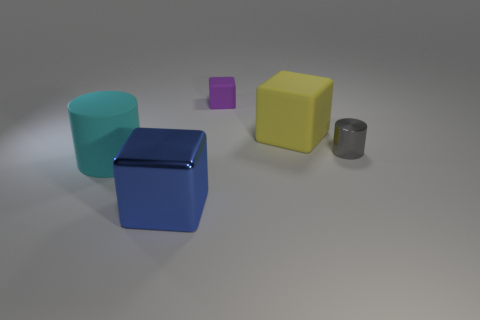Add 5 big yellow matte blocks. How many objects exist? 10 Subtract all purple objects. Subtract all gray cylinders. How many objects are left? 3 Add 4 large cyan cylinders. How many large cyan cylinders are left? 5 Add 1 small gray metal cylinders. How many small gray metal cylinders exist? 2 Subtract all purple cubes. How many cubes are left? 2 Subtract all yellow rubber blocks. How many blocks are left? 2 Subtract 1 blue blocks. How many objects are left? 4 Subtract all cubes. How many objects are left? 2 Subtract 1 blocks. How many blocks are left? 2 Subtract all cyan cubes. Subtract all green cylinders. How many cubes are left? 3 